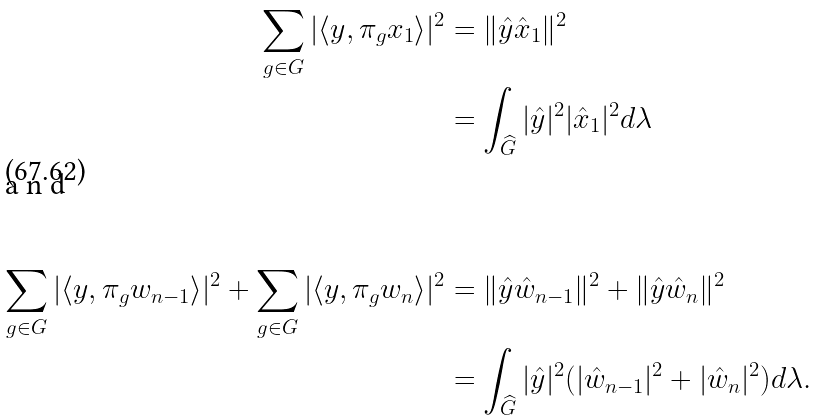<formula> <loc_0><loc_0><loc_500><loc_500>\sum _ { g \in G } | \langle y , \pi _ { g } x _ { 1 } \rangle | ^ { 2 } & = \| \hat { y } \hat { x } _ { 1 } \| ^ { 2 } \\ & = \int _ { \widehat { G } } | \hat { y } | ^ { 2 } | \hat { x } _ { 1 } | ^ { 2 } d \lambda \\ \intertext { a n d } \\ \sum _ { g \in G } | \langle y , \pi _ { g } w _ { n - 1 } \rangle | ^ { 2 } + \sum _ { g \in G } | \langle y , \pi _ { g } w _ { n } \rangle | ^ { 2 } & = \| \hat { y } \hat { w } _ { n - 1 } \| ^ { 2 } + \| \hat { y } \hat { w } _ { n } \| ^ { 2 } \\ & = \int _ { \widehat { G } } | \hat { y } | ^ { 2 } ( | \hat { w } _ { n - 1 } | ^ { 2 } + | \hat { w } _ { n } | ^ { 2 } ) d \lambda .</formula> 